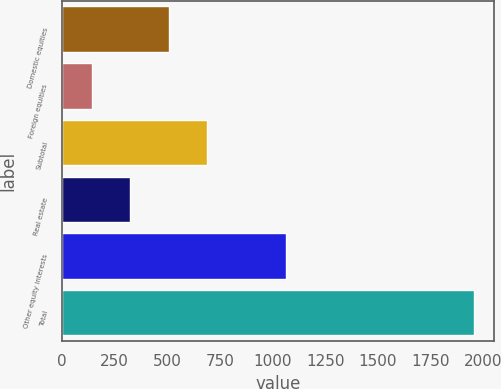Convert chart. <chart><loc_0><loc_0><loc_500><loc_500><bar_chart><fcel>Domestic equities<fcel>Foreign equities<fcel>Subtotal<fcel>Real estate<fcel>Other equity interests<fcel>Total<nl><fcel>506.4<fcel>144<fcel>687.6<fcel>325.2<fcel>1066<fcel>1956<nl></chart> 